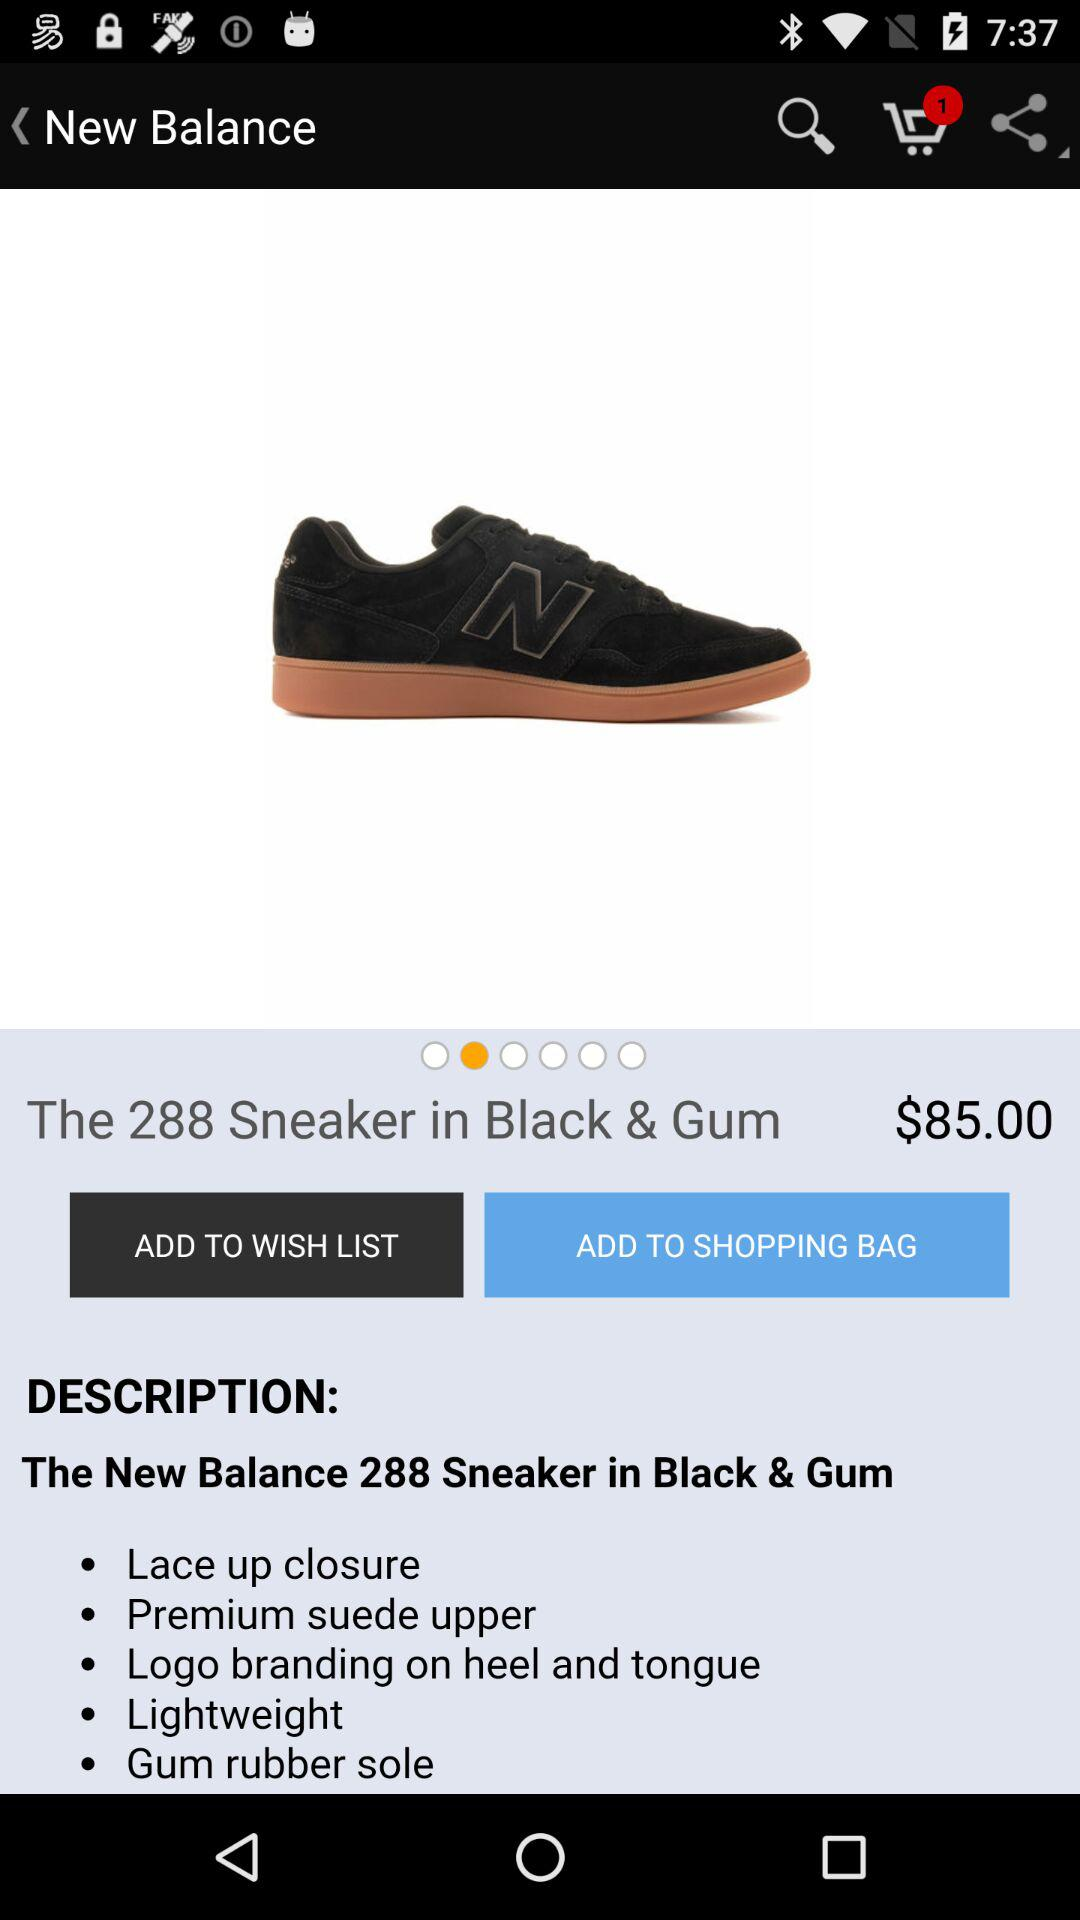How many items are in the cart? There is 1 item. 